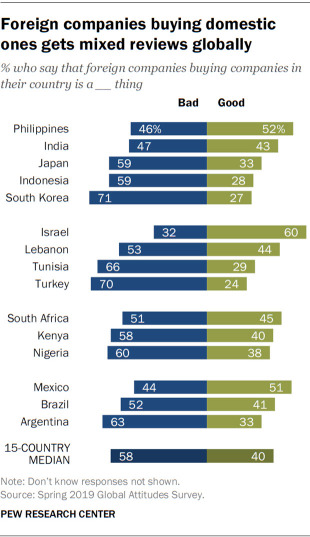Specify some key components in this picture. The data is 47 and 43 in India. The median data from 15 countries is 2.444444444... 